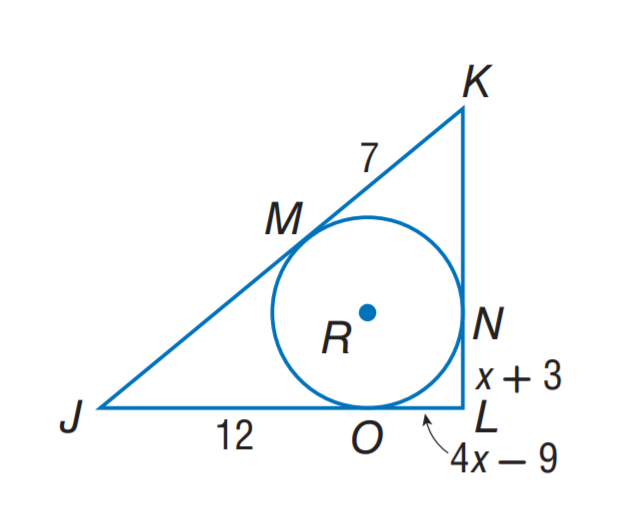Answer the mathemtical geometry problem and directly provide the correct option letter.
Question: Triangle J K L is circumscribed about \odot R. Find x.
Choices: A: 3 B: 4 C: 7 D: 9 B 